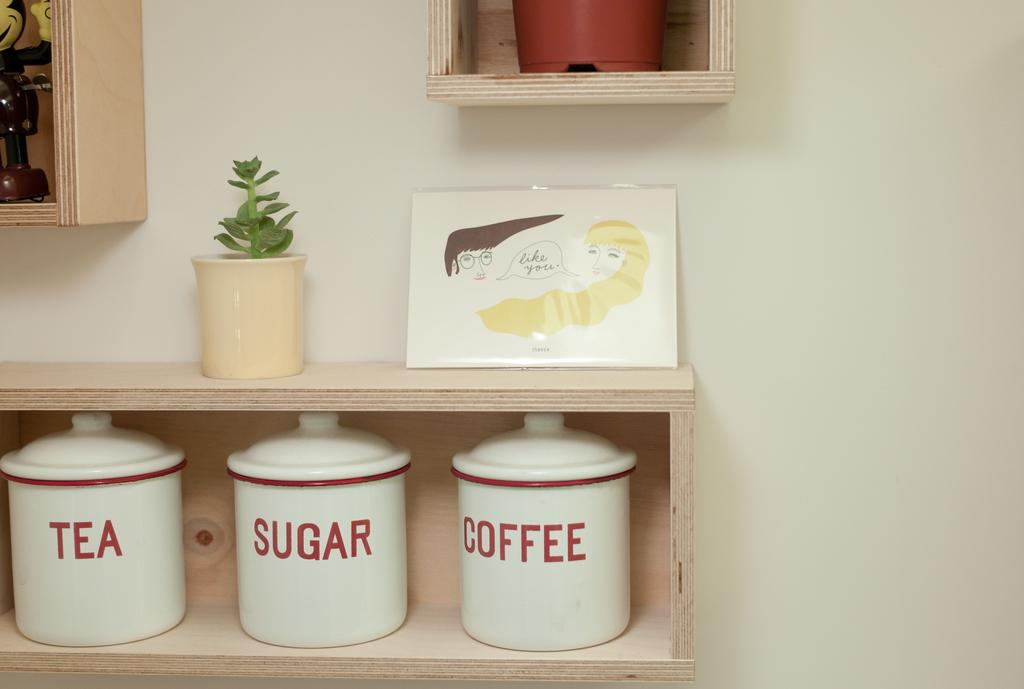<image>
Provide a brief description of the given image. Three jars  on a shelf are labeled Tea, Sugar, and Coffee. 